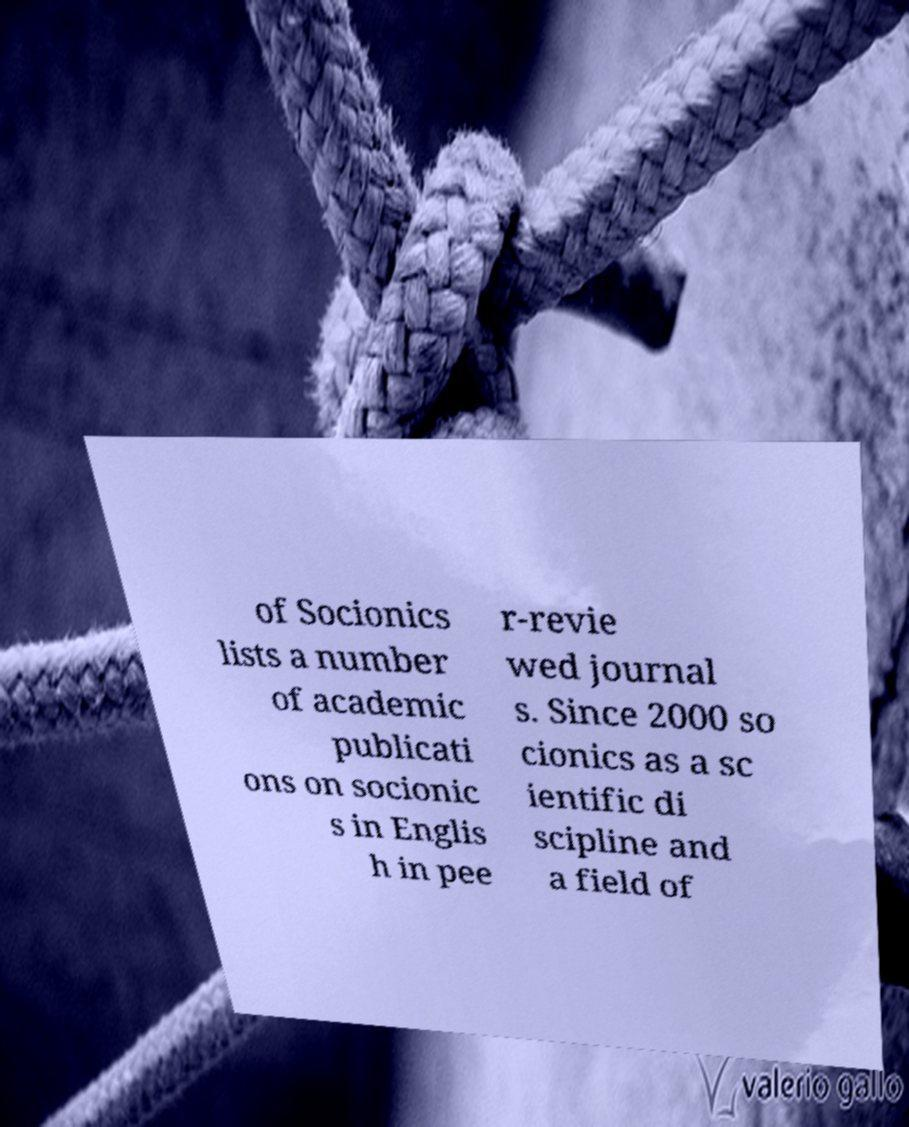Please read and relay the text visible in this image. What does it say? of Socionics lists a number of academic publicati ons on socionic s in Englis h in pee r-revie wed journal s. Since 2000 so cionics as a sc ientific di scipline and a field of 